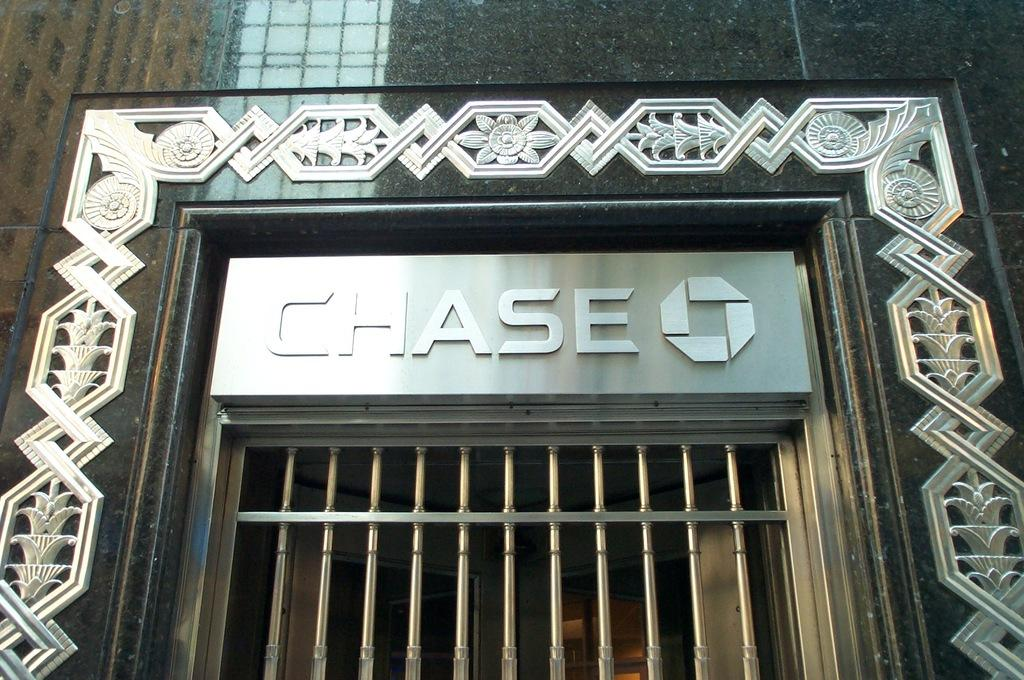What type of view is shown in the image? The image is a front view of a building. What can be seen on the building in the image? There is a board visible on the building. What architectural feature is present in the image? There is a grille in the image. What color is the sky in the image? There is no sky visible in the image, as it is a front view of a building. 